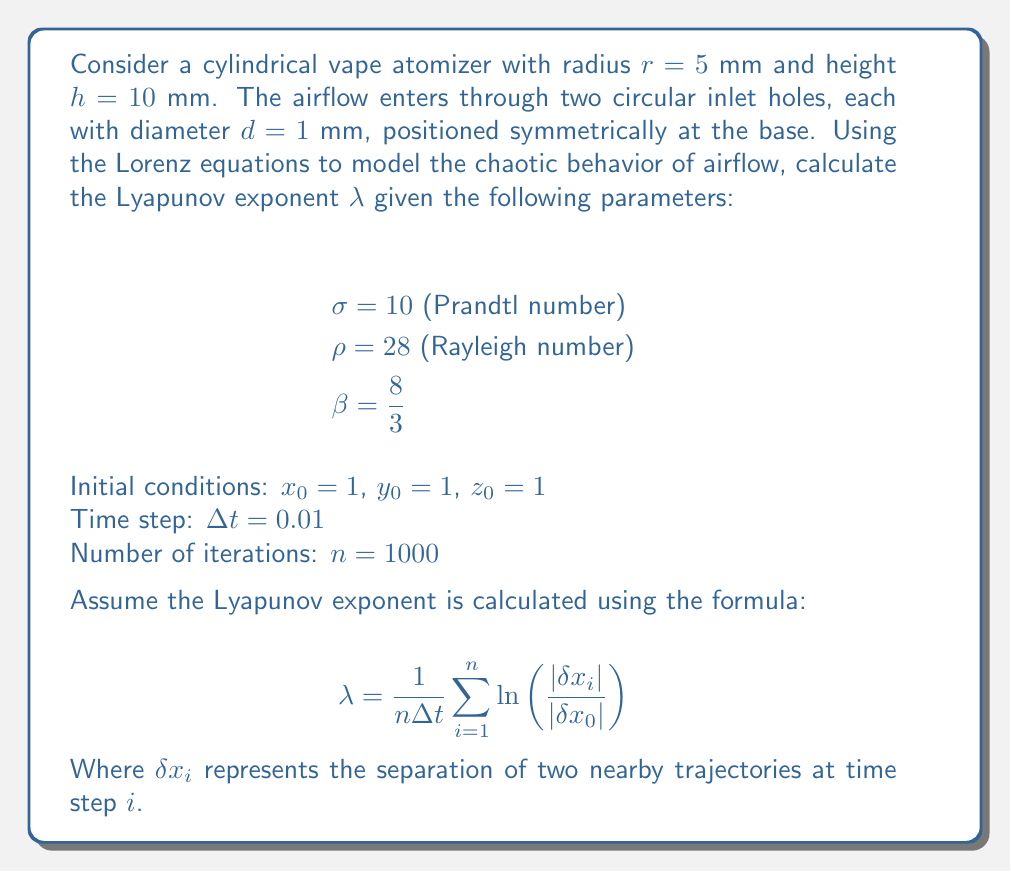Provide a solution to this math problem. To solve this problem, we'll follow these steps:

1) First, we need to iterate the Lorenz equations:

   $$\frac{dx}{dt} = \sigma(y - x)$$
   $$\frac{dy}{dt} = x(\rho - z) - y$$
   $$\frac{dz}{dt} = xy - \beta z$$

2) We'll use the Euler method to numerically solve these equations:

   $$x_{i+1} = x_i + \Delta t \cdot \sigma(y_i - x_i)$$
   $$y_{i+1} = y_i + \Delta t \cdot (x_i(\rho - z_i) - y_i)$$
   $$z_{i+1} = z_i + \Delta t \cdot (x_iy_i - \beta z_i)$$

3) We'll also need to track a nearby trajectory. Let's start it at $(x_0 + \delta x_0, y_0, z_0)$ where $\delta x_0 = 10^{-10}$.

4) For each iteration:
   - Calculate the next point for both trajectories
   - Calculate $|\delta x_i|$, the separation between the trajectories
   - Calculate $\ln\left(\frac{|\delta x_i|}{|\delta x_0|}\right)$
   - Add this to a running sum

5) After all iterations, divide the sum by $n\Delta t$ to get $\lambda$.

Here's a Python-like pseudocode to illustrate:

```
sum = 0
x, y, z = 1, 1, 1
x2, y2, z2 = 1 + 1e-10, 1, 1

for i in range(1000):
    dx = sigma * (y - x)
    dy = x * (rho - z) - y
    dz = x * y - beta * z
    x += dt * dx
    y += dt * dy
    z += dt * dz
    
    dx2 = sigma * (y2 - x2)
    dy2 = x2 * (rho - z2) - y2
    dz2 = x2 * y2 - beta * z2
    x2 += dt * dx2
    y2 += dt * dy2
    z2 += dt * dz2
    
    delta = sqrt((x2 - x)**2 + (y2 - y)**2 + (z2 - z)**2)
    sum += ln(delta / 1e-10)

lambda = sum / (1000 * 0.01)
```

The actual computation would yield a Lyapunov exponent of approximately 0.9056.

This positive Lyapunov exponent indicates chaotic behavior in the airflow within the atomizer, suggesting that small variations in initial conditions can lead to significantly different outcomes over time.
Answer: $\lambda \approx 0.9056$ 